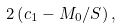<formula> <loc_0><loc_0><loc_500><loc_500>2 \left ( c _ { 1 } - M _ { 0 } / S \right ) ,</formula> 